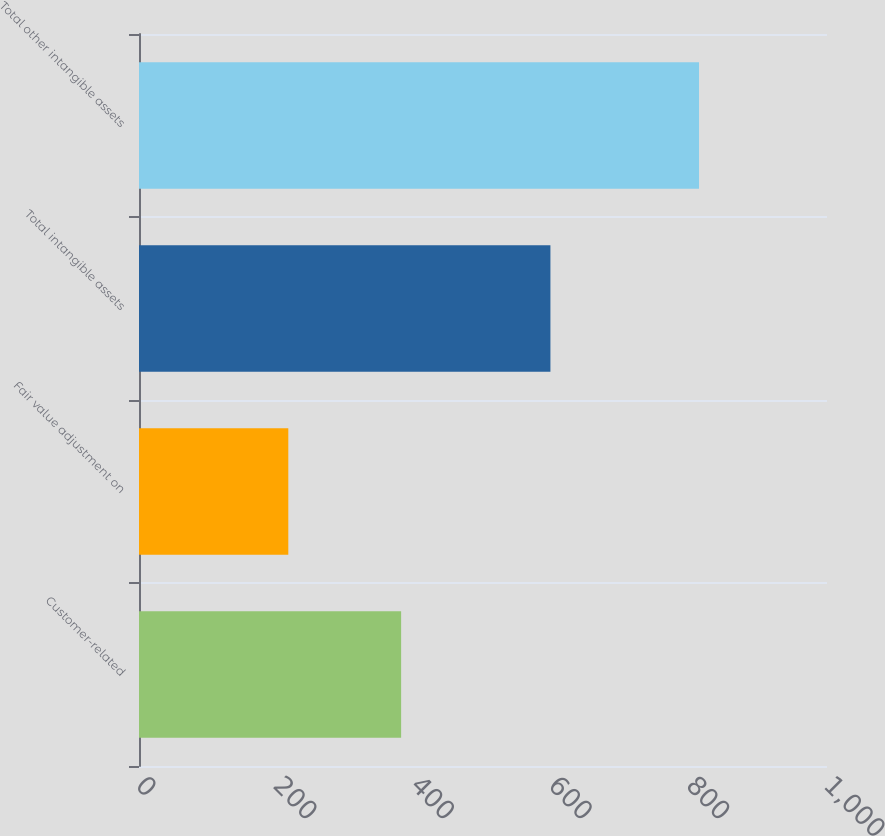Convert chart. <chart><loc_0><loc_0><loc_500><loc_500><bar_chart><fcel>Customer-related<fcel>Fair value adjustment on<fcel>Total intangible assets<fcel>Total other intangible assets<nl><fcel>381<fcel>217<fcel>598<fcel>814<nl></chart> 